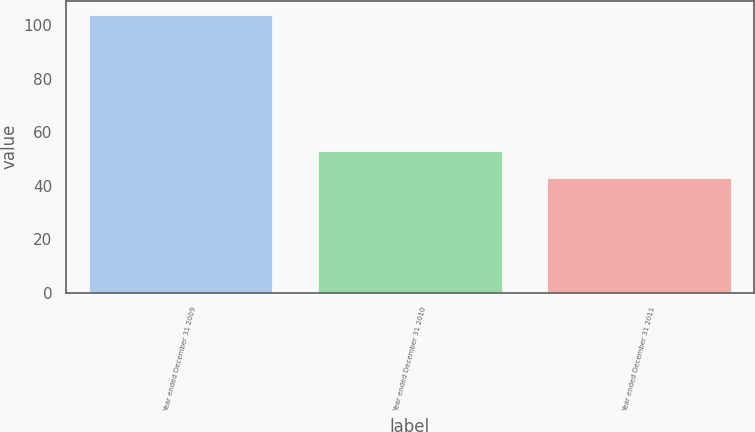<chart> <loc_0><loc_0><loc_500><loc_500><bar_chart><fcel>Year ended December 31 2009<fcel>Year ended December 31 2010<fcel>Year ended December 31 2011<nl><fcel>104<fcel>53<fcel>43<nl></chart> 